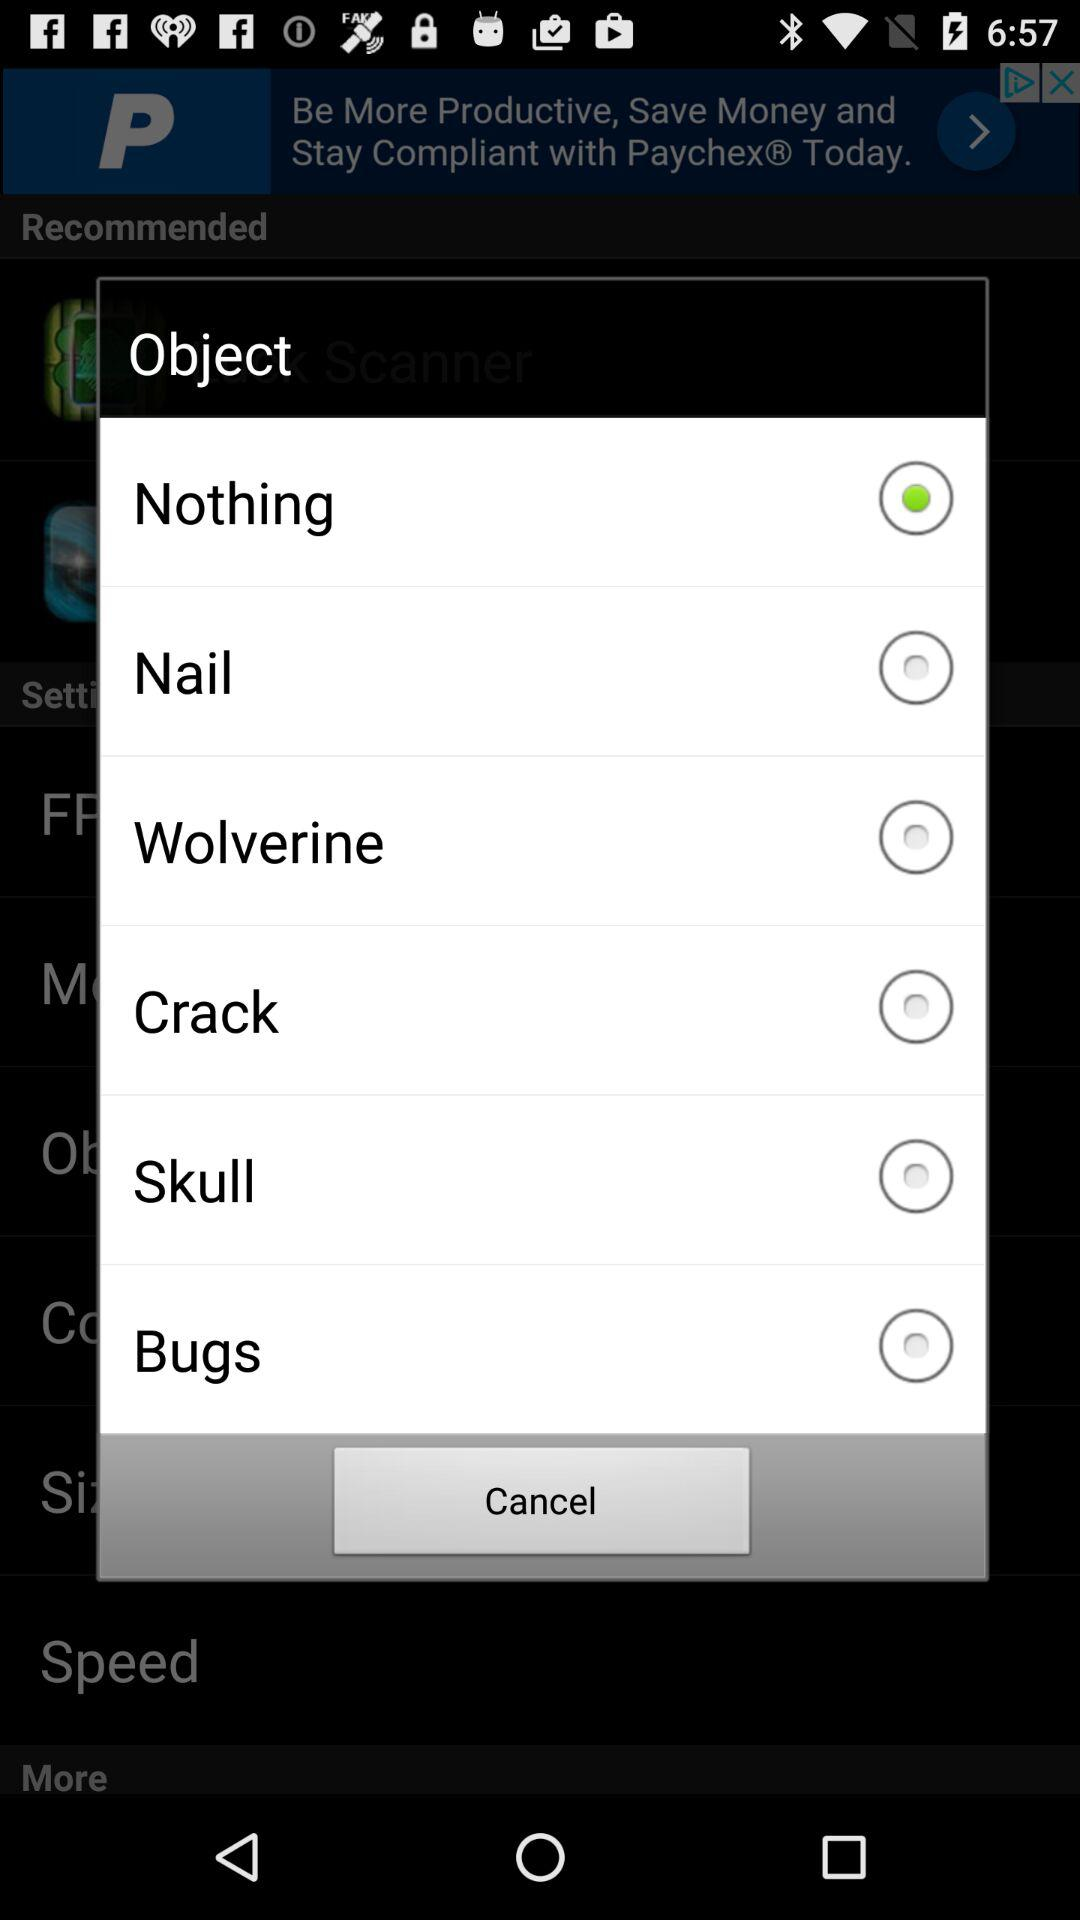What option is selected for the object? The selected option is "Nothing". 